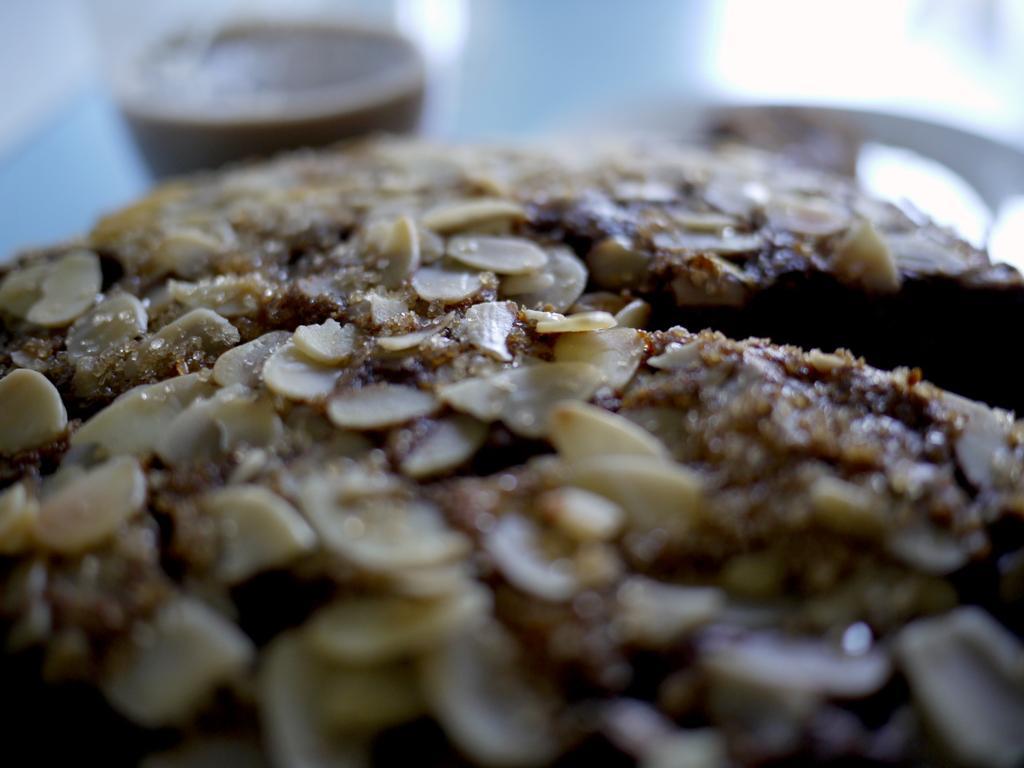Can you describe this image briefly? In this picture, we can see some food item and the blurred background. 